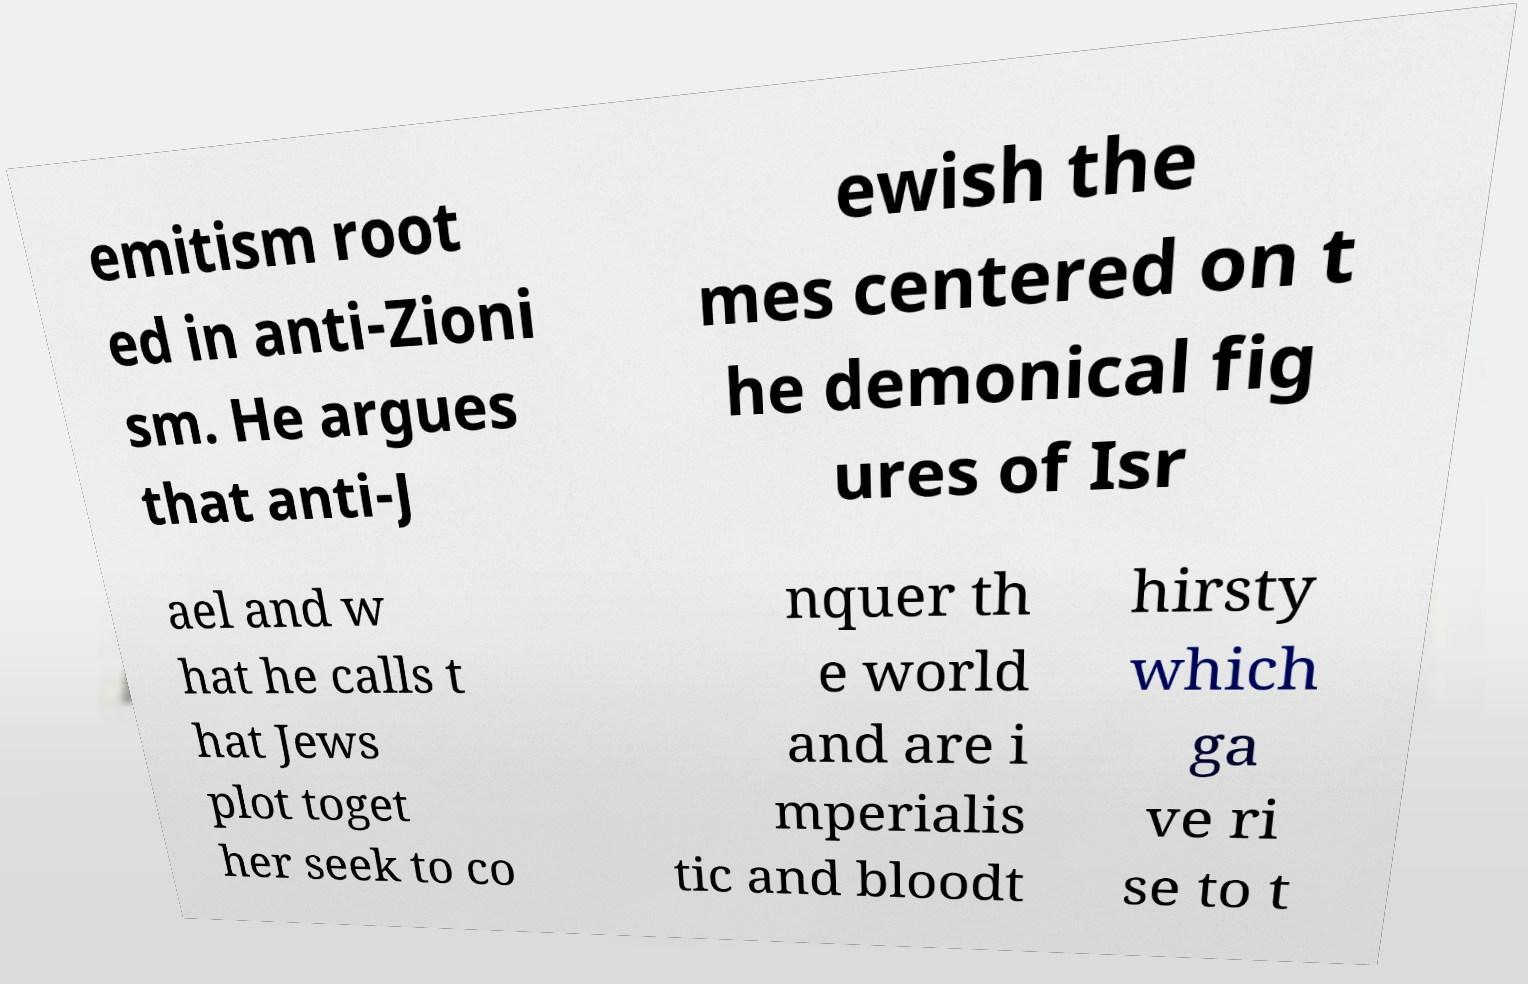Please identify and transcribe the text found in this image. emitism root ed in anti-Zioni sm. He argues that anti-J ewish the mes centered on t he demonical fig ures of Isr ael and w hat he calls t hat Jews plot toget her seek to co nquer th e world and are i mperialis tic and bloodt hirsty which ga ve ri se to t 